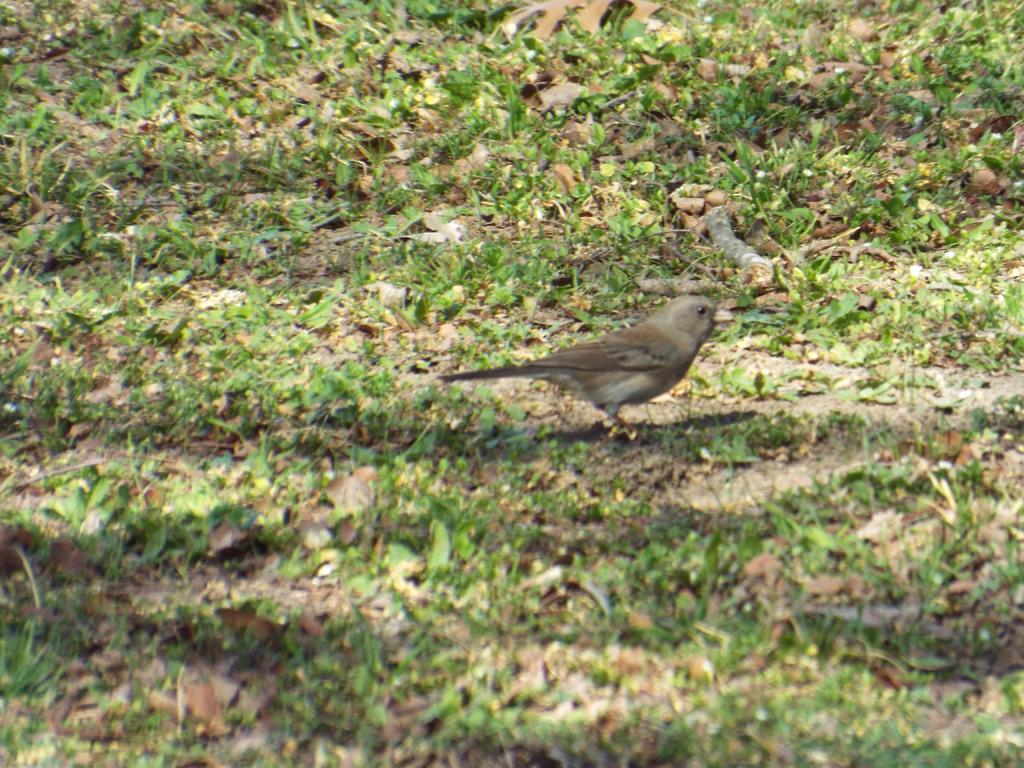What type of animal is on the ground in the image? There is a bird on the ground in the image. What else can be seen on the ground besides the bird? There are dried leaves and grass on the ground. What type of writing can be seen on the gravestone in the image? There is no gravestone or writing present in the image; it features a bird on the ground with dried leaves and grass. 